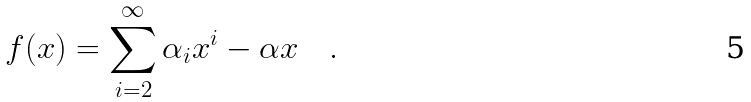<formula> <loc_0><loc_0><loc_500><loc_500>f ( x ) = \sum _ { i = 2 } ^ { \infty } \alpha _ { i } x ^ { i } - \alpha x \quad .</formula> 